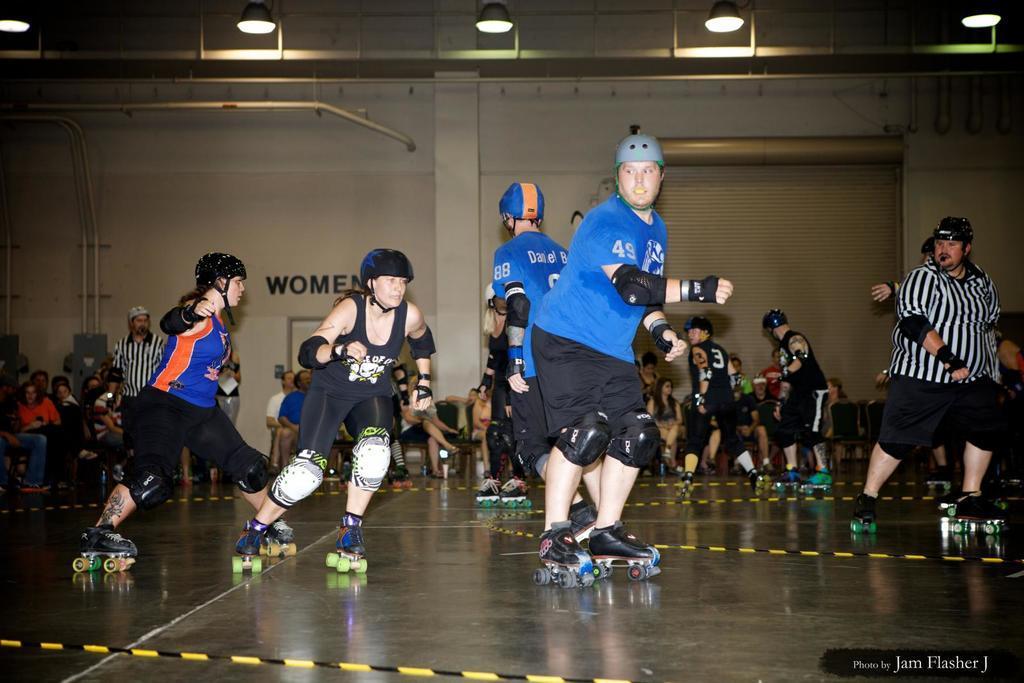Can you describe this image briefly? In this image I can see the group of people with different color dresses. I can see these people with the skate wheels. To the side I can see few more people sitting. In the background I can see the shutter and the wall. I can also see the lights in the top. 